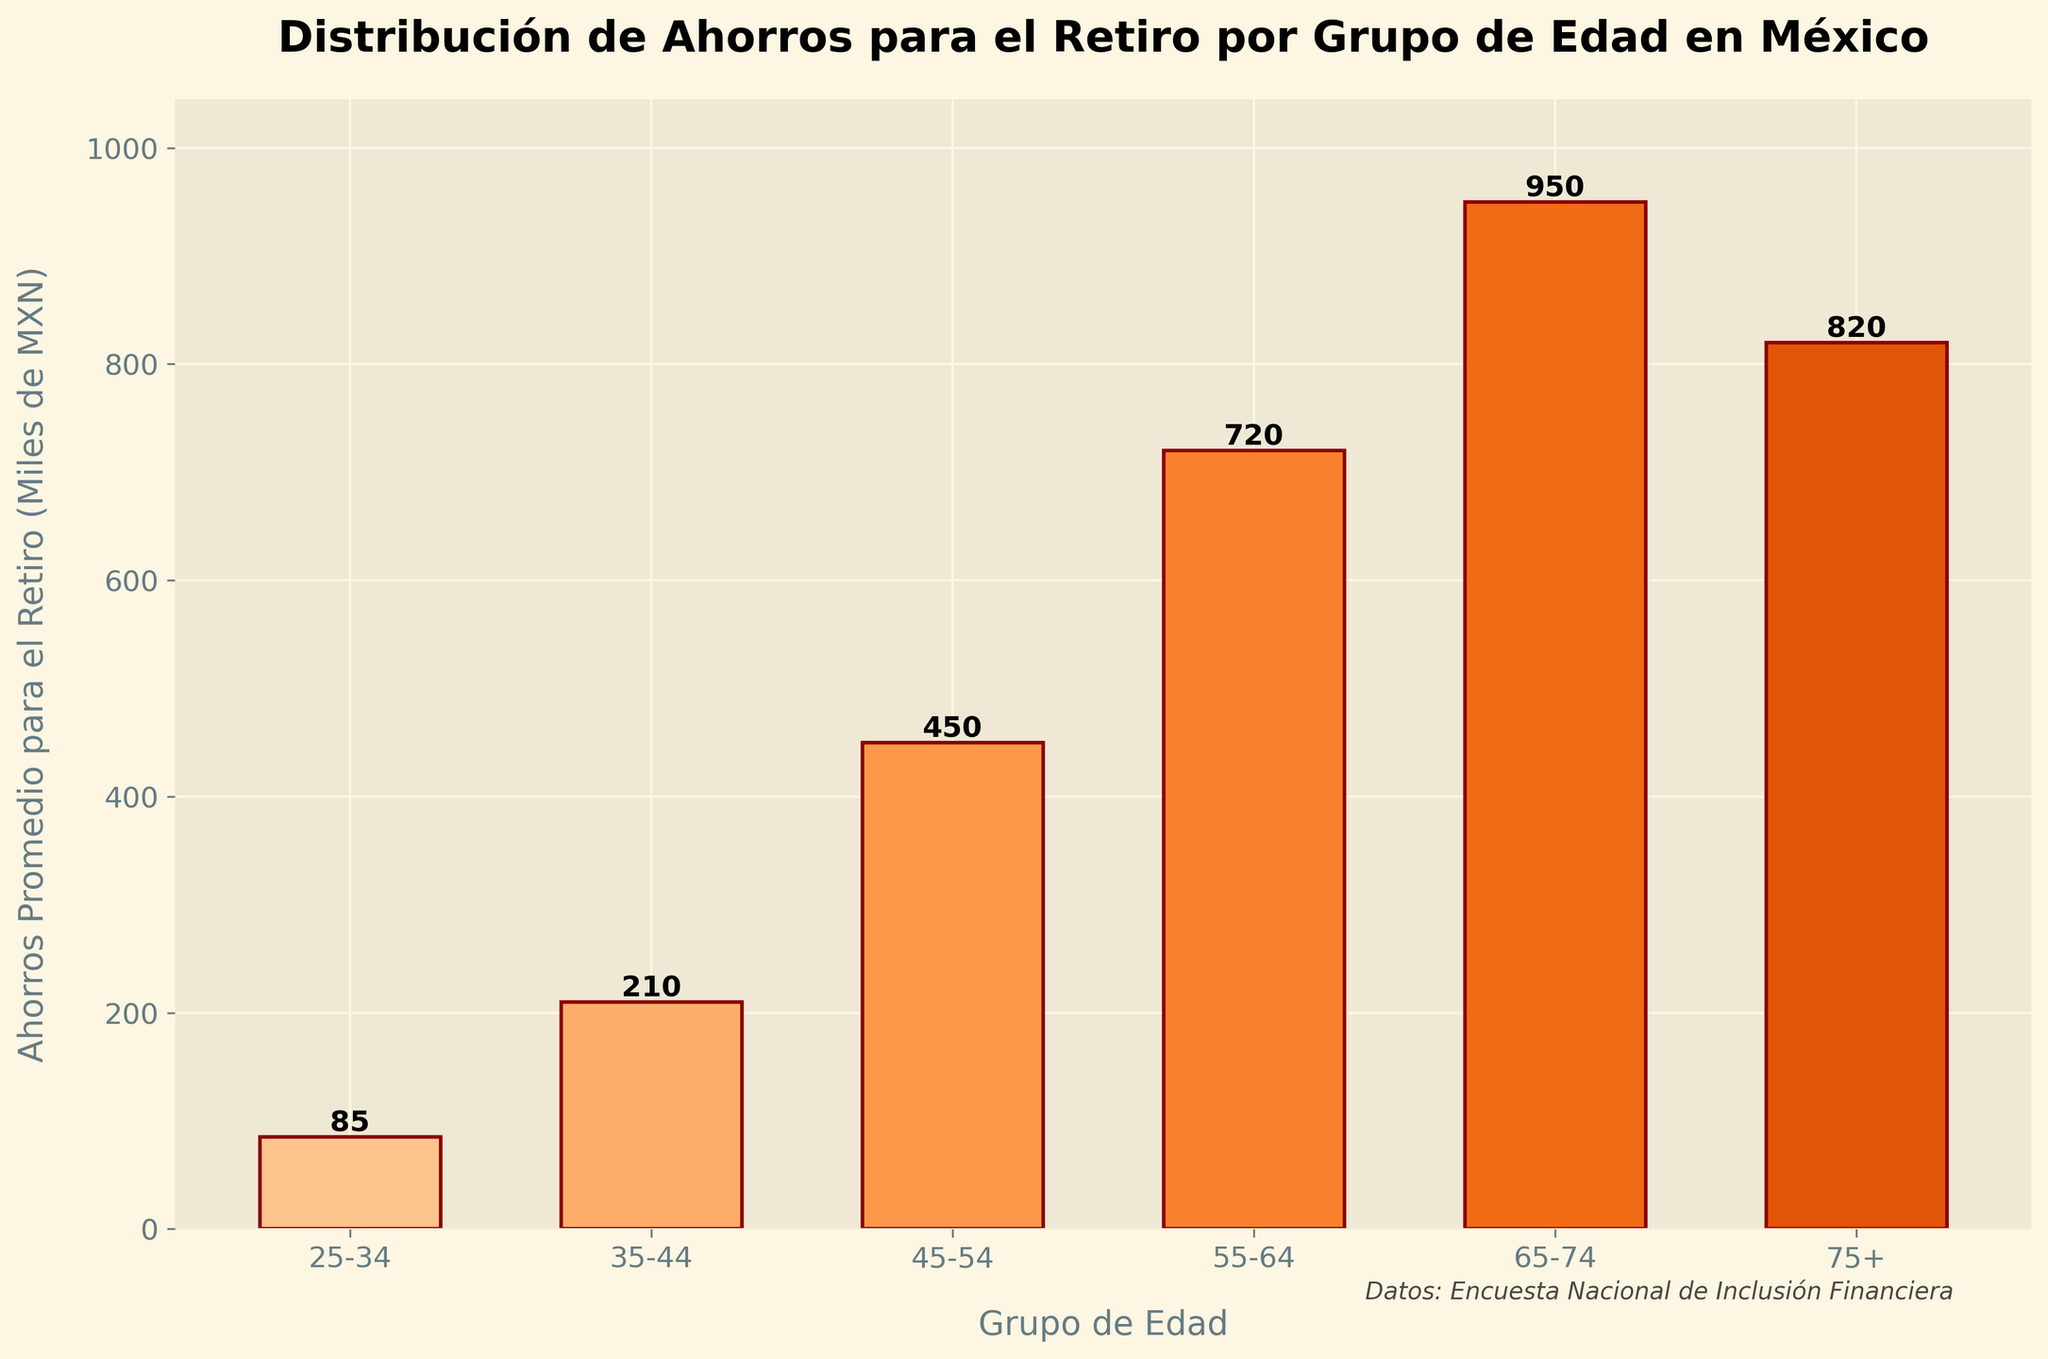Which age group has the highest average retirement savings? Look at the height of the bars in the figure. The tallest bar represents the age group 65-74 with average retirement savings of 950,000 MXN.
Answer: 65-74 How much more retirement savings do the 55-64 age group have compared to the 25-34 age group? The average retirement savings for the 55-64 age group is 720,000 MXN, and for the 25-34 age group, it is 85,000 MXN. The difference is 720,000 - 85,000 = 635,000 MXN.
Answer: 635,000 MXN Which age group has the lowest average retirement savings? Look at the height of the bars in the figure. The shortest bar represents the age group 25-34 with average retirement savings of 85,000 MXN.
Answer: 25-34 What is the combined average retirement savings of the 35-44 and 45-54 age groups? The average retirement savings for the 35-44 age group is 210,000 MXN and for the 45-54 age group, it is 450,000 MXN. The combined savings are 210,000 + 450,000 = 660,000 MXN.
Answer: 660,000 MXN Which age groups have average retirement savings greater than 500,000 MXN? Look at the bars whose heights represent more than 500,000 MXN. These bars are for the age groups 55-64, 65-74, and 75+.
Answer: 55-64, 65-74, 75+ By how much do the average retirement savings of the 65-74 age group exceed that of the 75+ age group? The average retirement savings for the 65-74 age group is 950,000 MXN, and for the 75+ age group, it is 820,000 MXN. The difference is 950,000 - 820,000 = 130,000 MXN.
Answer: 130,000 MXN What is the average retirement savings across all age groups? First, sum up the average retirement savings for all the age groups: 85,000 + 210,000 + 450,000 + 720,000 + 950,000 + 820,000 = 3,235,000 MXN. Then, divide by the number of age groups, which is 6: 3,235,000 / 6 = 539,167 MXN.
Answer: 539,167 MXN How does the average retirement savings of the 25-34 age group compare to the 75+ age group? The average retirement savings for the 25-34 age group is 85,000 MXN, and for the 75+ age group, it is 820,000 MXN. The 75+ group has significantly higher savings at 820,000 MXN.
Answer: 75+ group has higher savings 